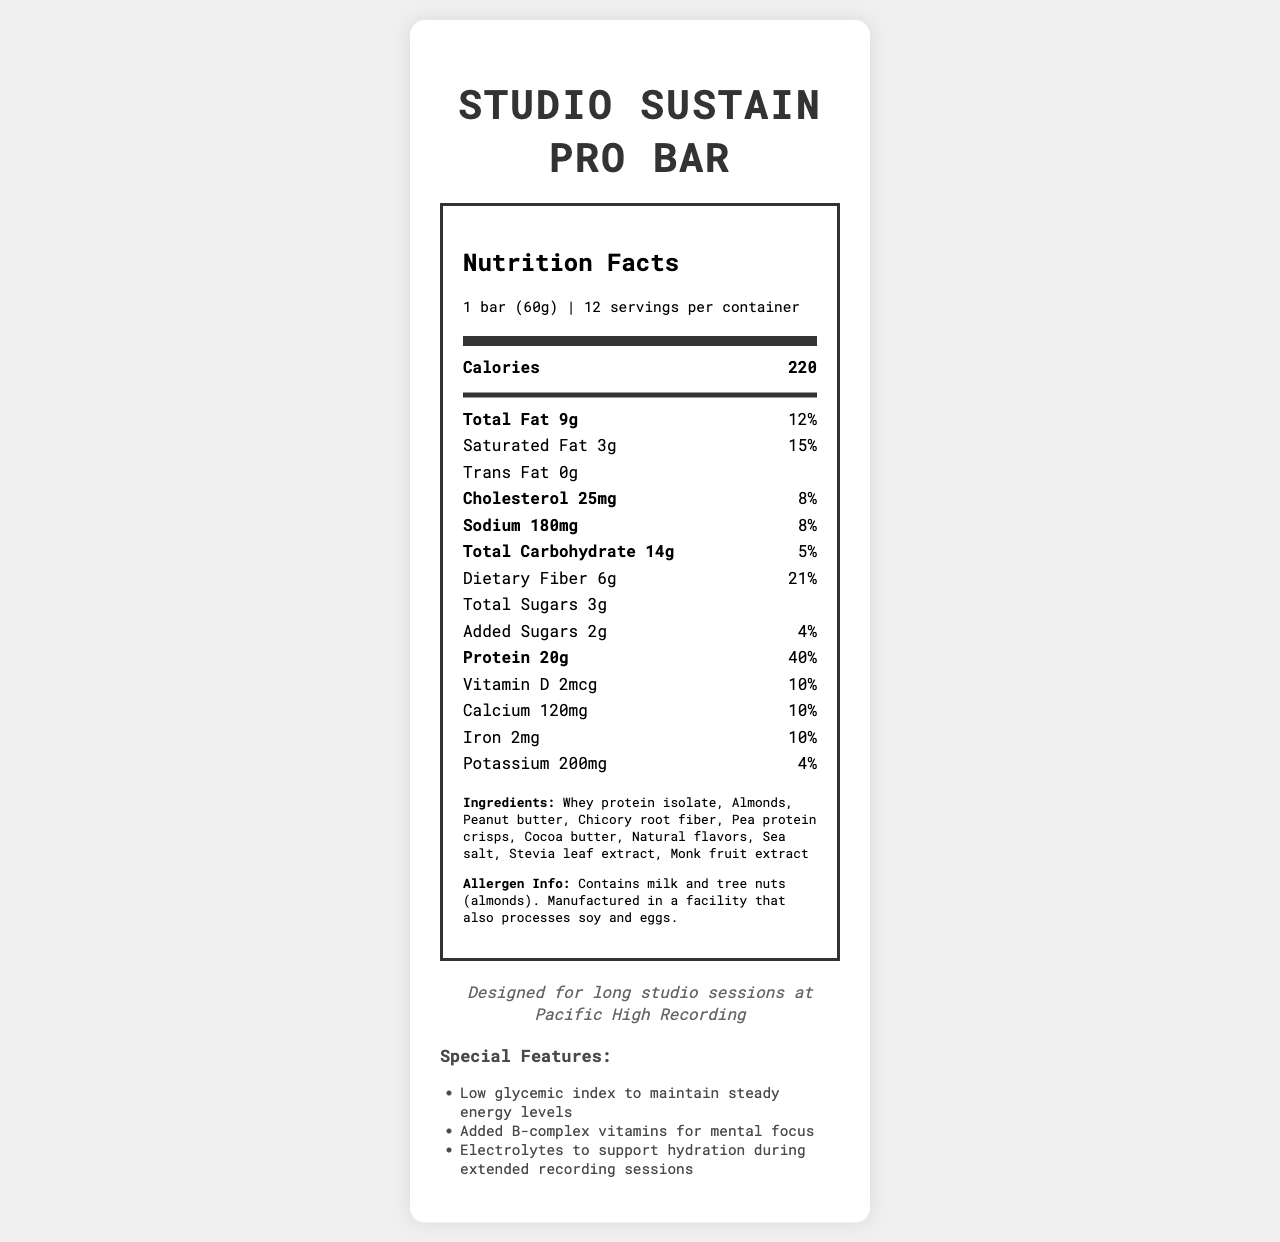what is the serving size? The serving size is stated in the "serving_info" section as "1 bar (60g)".
Answer: 1 bar (60g) how many calories are in one serving? The calorie content is highlighted in the main nutrient section right at the beginning.
Answer: 220 what percentage of daily value is the total fat? The total fat daily value is provided next to the amount of fat, which is 12%.
Answer: 12% how many grams of protein are in each serving? The protein content per serving is listed as "20g" under the nutrient section.
Answer: 20g what is the total carbohydrates percentage of daily value? The daily value percentage for total carbohydrates is stated as 5%.
Answer: 5% what allergens may be present in the bar? The allergen information section lists milk and tree nuts (almonds) and mentions the manufacturing facility also processes soy and eggs.
Answer: Contains milk and tree nuts (almonds). Manufactured in a facility that also processes soy and eggs. what are the ingredients of the snack bar? The ingredients are listed under the "ingredients" section.
Answer: Whey protein isolate, Almonds, Peanut butter, Chicory root fiber, Pea protein crisps, Cocoa butter, Natural flavors, Sea salt, Stevia leaf extract, Monk fruit extract which vitamin is included to enhance mental focus? A. Vitamin A B. Vitamin B-complex C. Vitamin C D. Vitamin D The "special features" section mentions that the bar contains added B-complex vitamins for mental focus.
Answer: B. Vitamin B-complex how many servings are there in one container? The serving info states there are 12 servings per container.
Answer: 12 does this bar contain trans fat? It is specified in the nutrient section that there is "0g" of trans fat.
Answer: No does the bar support hydration during long studio sessions? The "special features" section mentions that electrolytes are added to support hydration during extended recording sessions.
Answer: Yes summarize the main idea of the document. The document combines all essential nutritional details, ingredients, special features tailored for studio professionals, and allergen information into a structured format, aimed at informing and assisting potential users in decision-making.
Answer: The document is a nutrition facts label for the "Studio Sustain Pro Bar", a high-protein, low-carb snack bar designed for long studio sessions. It provides detailed information on the serving size, calories, nutrient amounts, ingredients, allergen information, and special features like added vitamins and electrolytes for mental focus and hydration. what is the main source of fiber in the bar? The document provides the total dietary fiber content but does not specify which ingredient contributes most to the fiber content.
Answer: Cannot be determined 